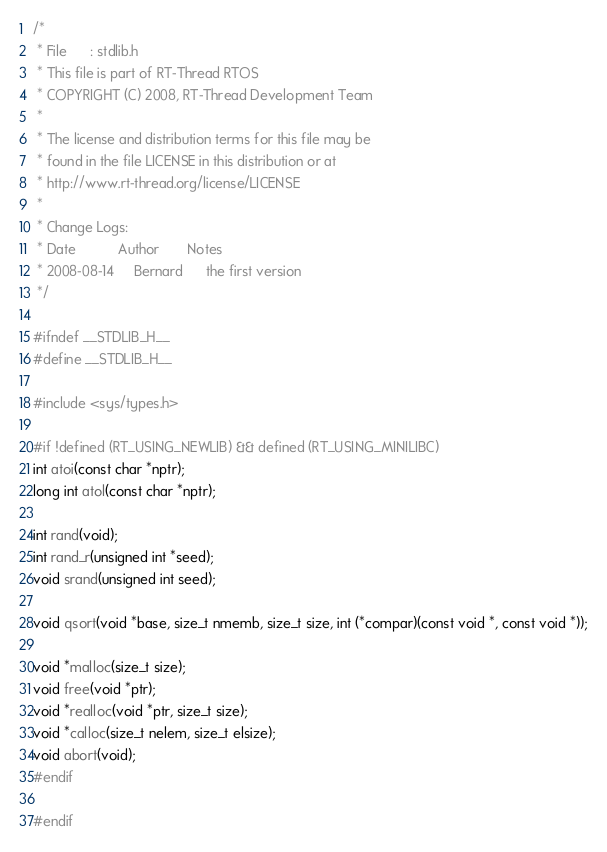Convert code to text. <code><loc_0><loc_0><loc_500><loc_500><_C_>/*
 * File      : stdlib.h
 * This file is part of RT-Thread RTOS
 * COPYRIGHT (C) 2008, RT-Thread Development Team
 *
 * The license and distribution terms for this file may be
 * found in the file LICENSE in this distribution or at
 * http://www.rt-thread.org/license/LICENSE
 *
 * Change Logs:
 * Date           Author       Notes
 * 2008-08-14     Bernard      the first version
 */

#ifndef __STDLIB_H__
#define __STDLIB_H__

#include <sys/types.h>

#if !defined (RT_USING_NEWLIB) && defined (RT_USING_MINILIBC)
int atoi(const char *nptr);
long int atol(const char *nptr);

int rand(void);
int rand_r(unsigned int *seed);
void srand(unsigned int seed);

void qsort(void *base, size_t nmemb, size_t size, int (*compar)(const void *, const void *));

void *malloc(size_t size);
void free(void *ptr);
void *realloc(void *ptr, size_t size);
void *calloc(size_t nelem, size_t elsize);
void abort(void);
#endif

#endif
</code> 